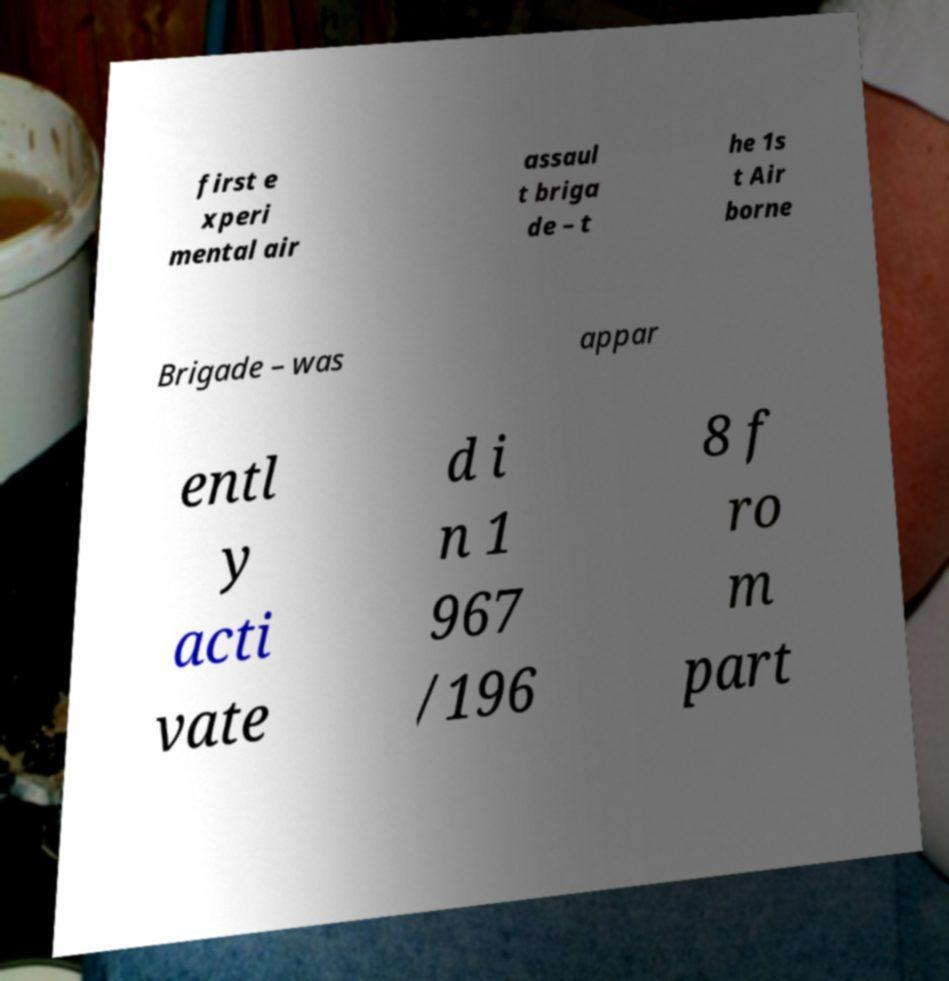Please identify and transcribe the text found in this image. first e xperi mental air assaul t briga de – t he 1s t Air borne Brigade – was appar entl y acti vate d i n 1 967 /196 8 f ro m part 